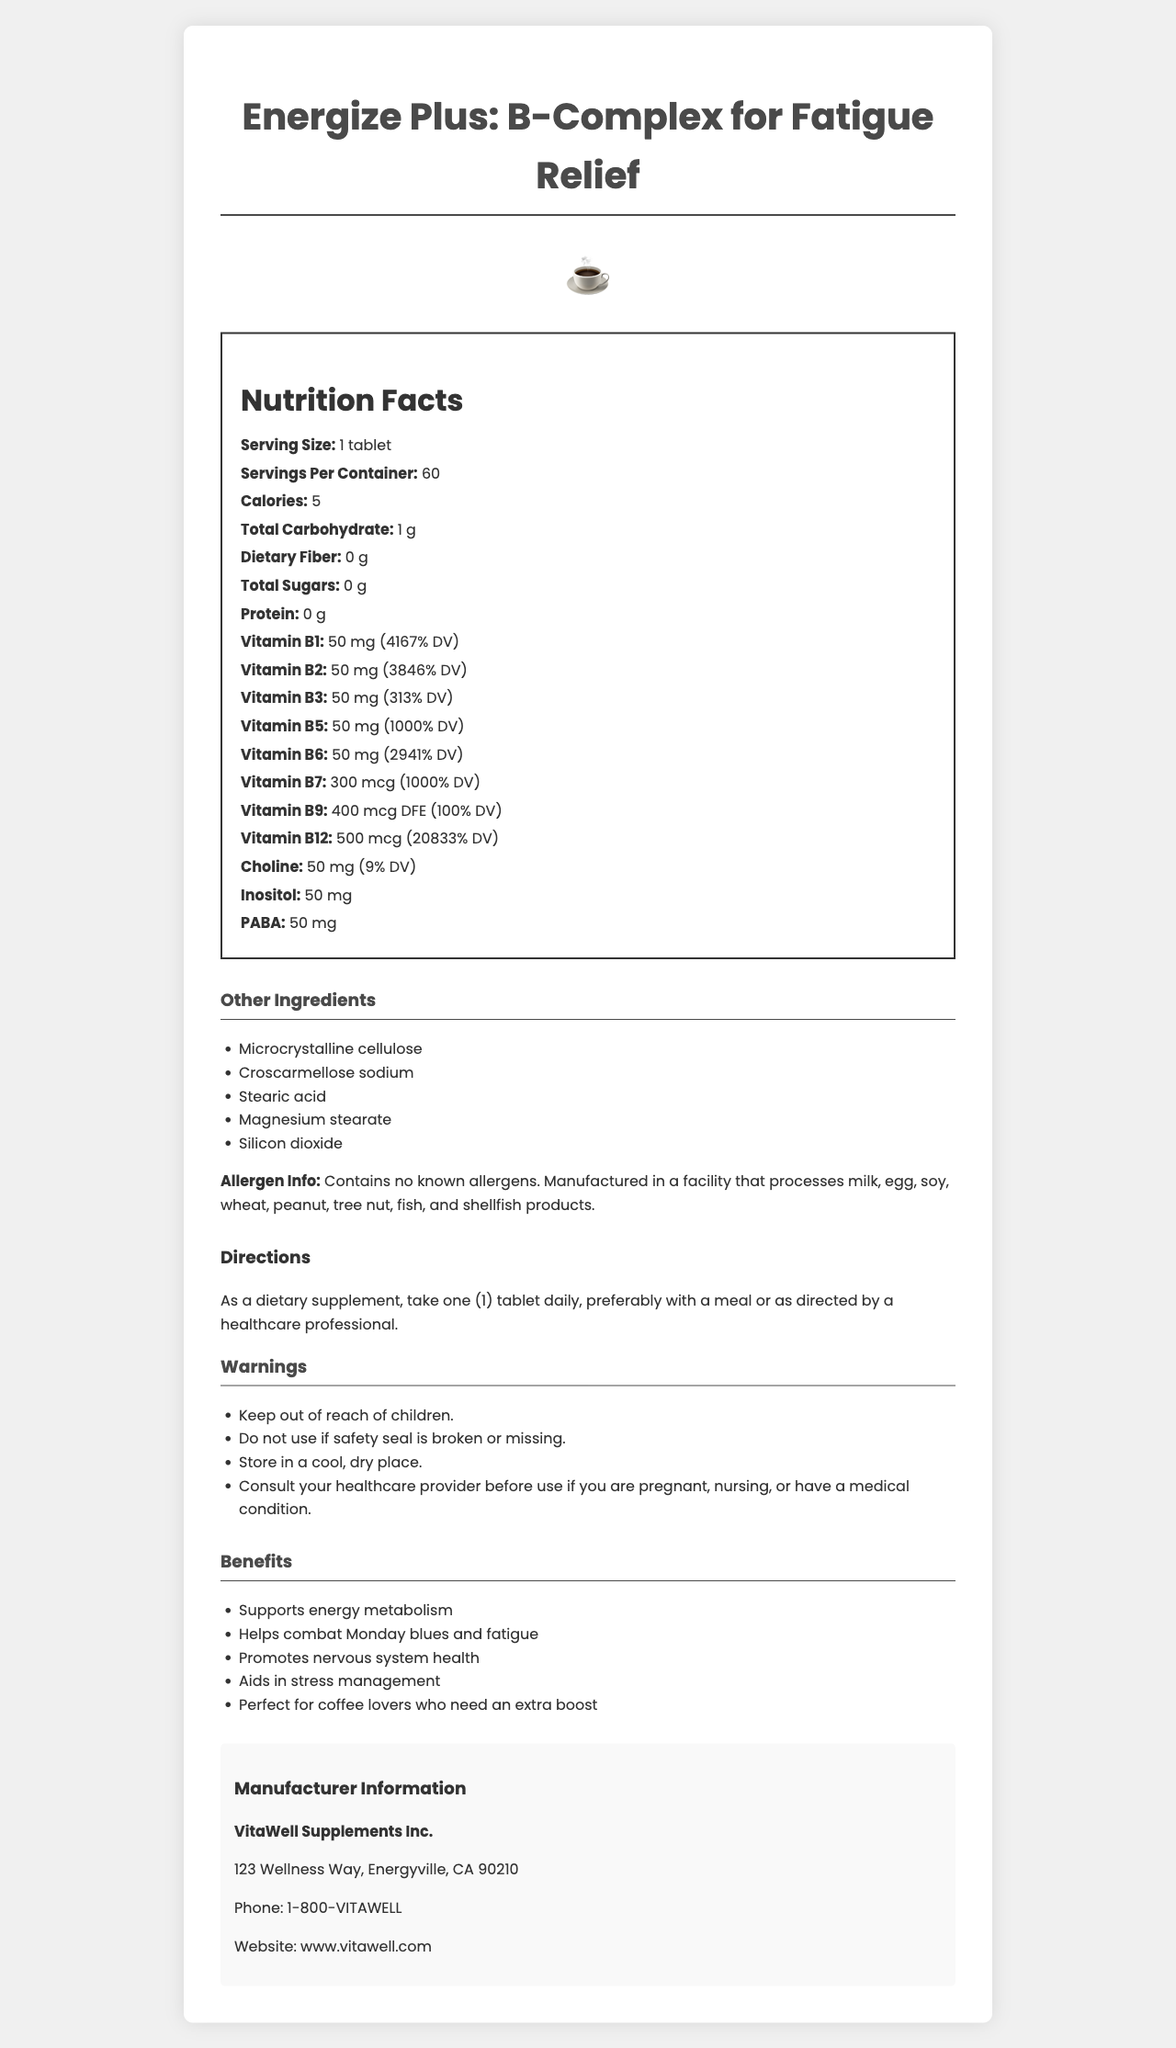what is the serving size of Energize Plus? The document states, "Serving Size: 1 tablet" in the Nutrition Facts section.
Answer: 1 tablet how many servings are there per container? The document states, "Servings Per Container: 60" in the Nutrition Facts section.
Answer: 60 how many calories are there per serving? The document states, "Calories: 5" in the Nutrition Facts section.
Answer: 5 what is the amount of Vitamin B12 per serving? The document states, "Vitamin B12: 500 mcg (20833% DV)" in the Nutrition Facts section.
Answer: 500 mcg what are the directions for taking this supplement? The directions are detailed under the "Directions" section: "As a dietary supplement, take one (1) tablet daily, preferably with a meal or as directed by a healthcare professional."
Answer: Take one (1) tablet daily, preferably with a meal or as directed by a healthcare professional. which ingredient is NOT included in the list of other ingredients? A. Microcrystalline cellulose B. Magnesium stearate C. Croscarmellose sodium D. Aspartame The ingredient list includes Microcrystalline cellulose, Magnesium stearate, and Croscarmellose sodium but does not include Aspartame.
Answer: D how much Vitamin B7 is in each serving? A. 50 mcg B. 300 mcg C. 500 mcg D. 700 mcg The document states, "Vitamin B7: 300 mcg (1000% DV)" in the Nutrition Facts section.
Answer: B true or false: This product contains allergens such as milk, egg, and soy. The document explicitly states, "Contains no known allergens," under the "Allergen Info" section.
Answer: False summarize the benefits of Energize Plus as highlighted in the document. The benefits are listed in the "Benefits" section and include several claims about how the supplement supports various aspects of health and energy levels.
Answer: Energize Plus supports energy metabolism, helps combat Monday blues and fatigue, promotes nervous system health, aids in stress management, and is ideal for coffee lovers who need an extra boost. which company manufactures Energize Plus? The document states the manufacturer's name under the "Manufacturer Information" section: "VitaWell Supplements Inc."
Answer: VitaWell Supplements Inc. how much Vitamin B1 is present per serving of Energize Plus? The document states, "Vitamin B1: 50 mg (4167% DV)" in the Nutrition Facts section.
Answer: 50 mg is there any dietary fiber in Energize Plus? The document states, "Dietary Fiber: 0 g" in the Nutrition Facts section.
Answer: No where is VitaWell Supplements Inc. located? The location is given under the "Manufacturer Information" section: "123 Wellness Way, Energyville, CA 90210."
Answer: 123 Wellness Way, Energyville, CA 90210 what is the daily value percentage for Vitamin B5? The document states, "Vitamin B5: 50 mg (1000% DV)" in the Nutrition Facts section.
Answer: 1000% is this supplement suitable for vegetarians? The document does not provide information about whether the supplement is suitable for vegetarians. It does not mention vegetarian suitability in the allergen info or any other sections.
Answer: Cannot be determined 